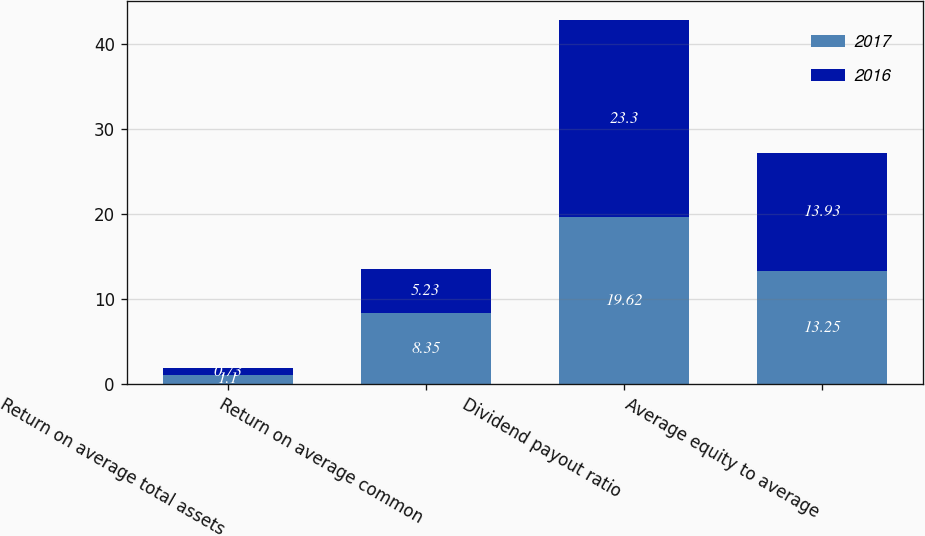Convert chart to OTSL. <chart><loc_0><loc_0><loc_500><loc_500><stacked_bar_chart><ecel><fcel>Return on average total assets<fcel>Return on average common<fcel>Dividend payout ratio<fcel>Average equity to average<nl><fcel>2017<fcel>1.1<fcel>8.35<fcel>19.62<fcel>13.25<nl><fcel>2016<fcel>0.73<fcel>5.23<fcel>23.3<fcel>13.93<nl></chart> 